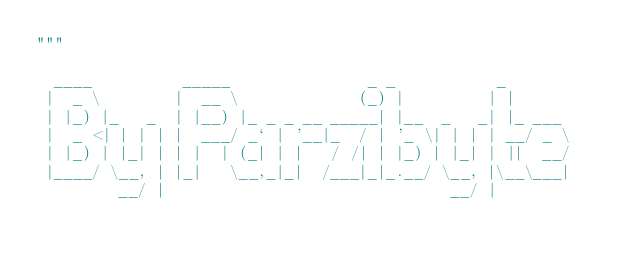<code> <loc_0><loc_0><loc_500><loc_500><_Python_>"""

  ____          _____               _ _           _       
 |  _ \        |  __ \             (_) |         | |      
 | |_) |_   _  | |__) |_ _ _ __ _____| |__  _   _| |_ ___ 
 |  _ <| | | | |  ___/ _` | '__|_  / | '_ \| | | | __/ _ \
 | |_) | |_| | | |  | (_| | |   / /| | |_) | |_| | ||  __/
 |____/ \__, | |_|   \__,_|_|  /___|_|_.__/ \__, |\__\___|
         __/ |                               __/ |        </code> 